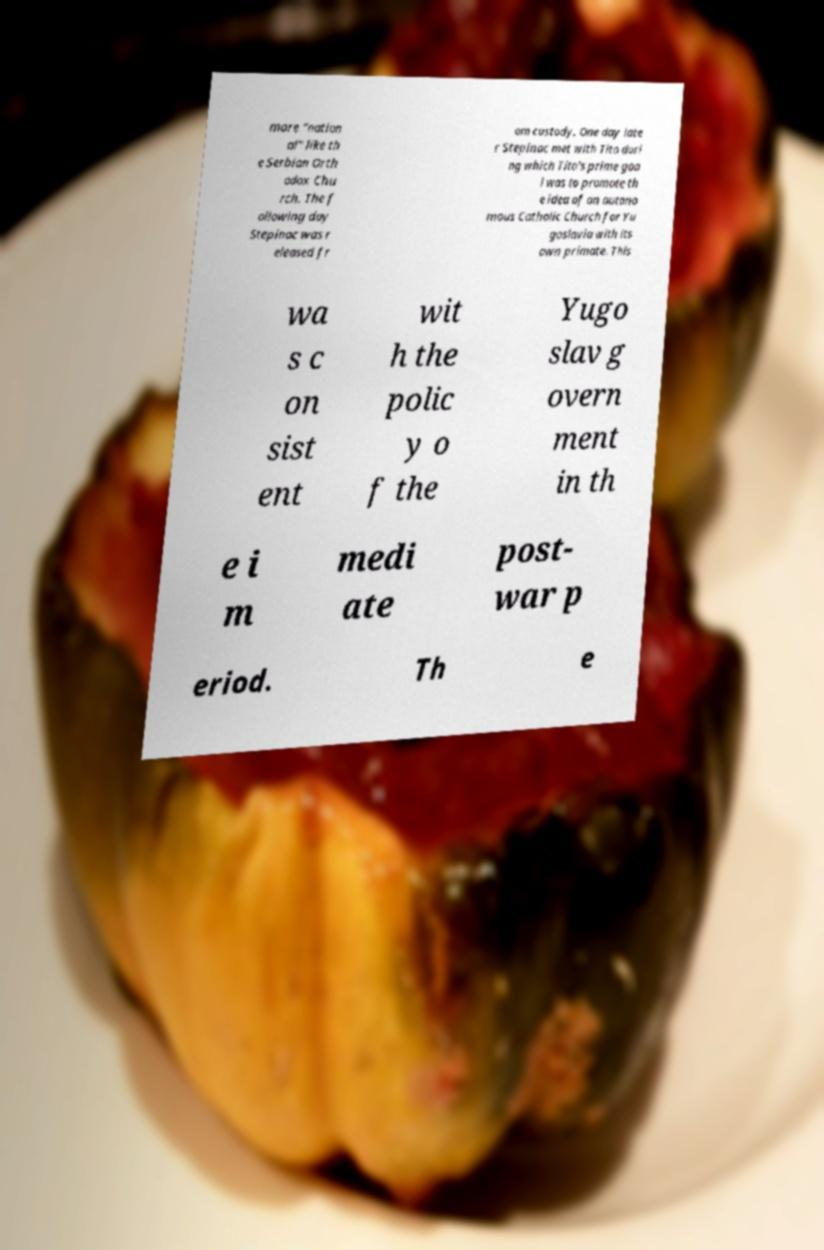Can you read and provide the text displayed in the image?This photo seems to have some interesting text. Can you extract and type it out for me? more "nation al" like th e Serbian Orth odox Chu rch. The f ollowing day Stepinac was r eleased fr om custody. One day late r Stepinac met with Tito duri ng which Tito's prime goa l was to promote th e idea of an autono mous Catholic Church for Yu goslavia with its own primate. This wa s c on sist ent wit h the polic y o f the Yugo slav g overn ment in th e i m medi ate post- war p eriod. Th e 